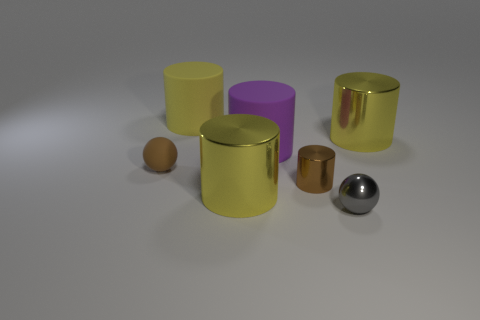Subtract all yellow cylinders. How many were subtracted if there are2yellow cylinders left? 1 Subtract all yellow balls. How many yellow cylinders are left? 3 Subtract all tiny metallic cylinders. How many cylinders are left? 4 Subtract all purple cylinders. How many cylinders are left? 4 Subtract all gray cylinders. Subtract all yellow cubes. How many cylinders are left? 5 Add 3 large yellow cylinders. How many objects exist? 10 Subtract all spheres. How many objects are left? 5 Add 5 gray shiny balls. How many gray shiny balls are left? 6 Add 7 tiny red metallic things. How many tiny red metallic things exist? 7 Subtract 1 gray spheres. How many objects are left? 6 